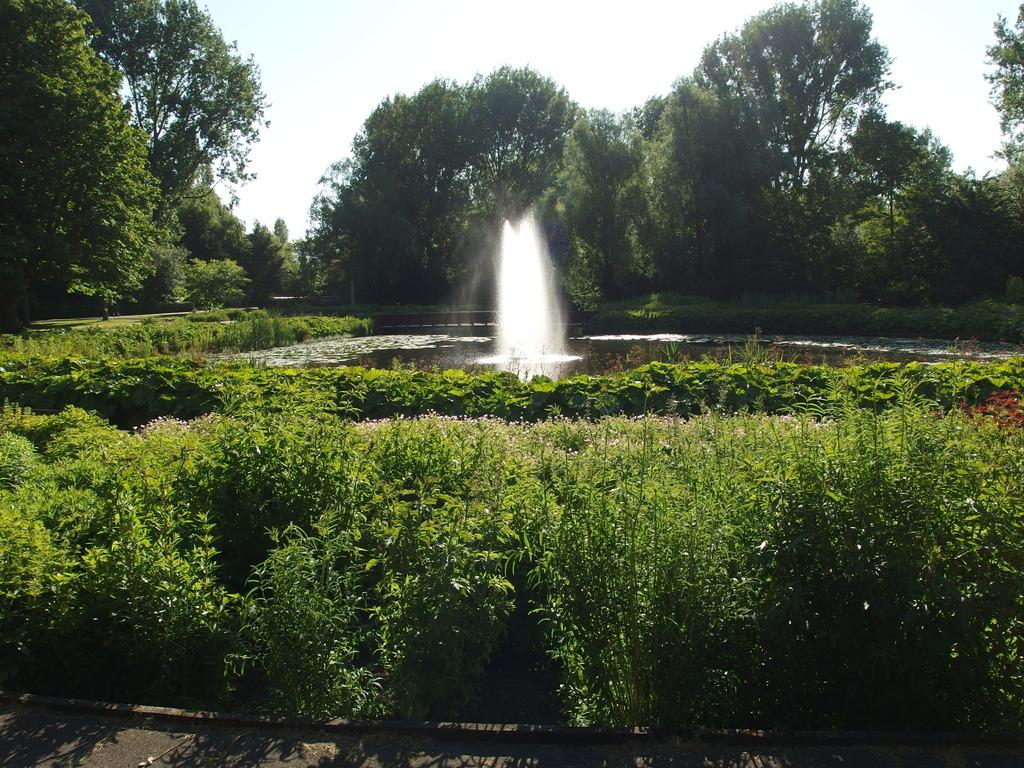What is the main feature in the center of the image? There is a fountain in the center of the image. What can be seen in front of the image? There is a road in front of the image. What type of vegetation is visible in the image? There are plants visible in the image. What is visible in the background of the image? There are trees and the sky visible in the background of the image. What type of soup is being served in the fountain in the image? There is no soup present in the image; it features a fountain in the center. Can you tell me how many dogs are visible in the image? There are no dogs present in the image. 